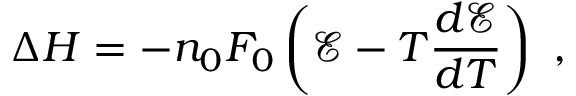<formula> <loc_0><loc_0><loc_500><loc_500>\Delta H = - n _ { 0 } F _ { 0 } \left ( { \mathcal { E } } - T { \frac { d { \mathcal { E } } } { d T } } \right ) \ ,</formula> 